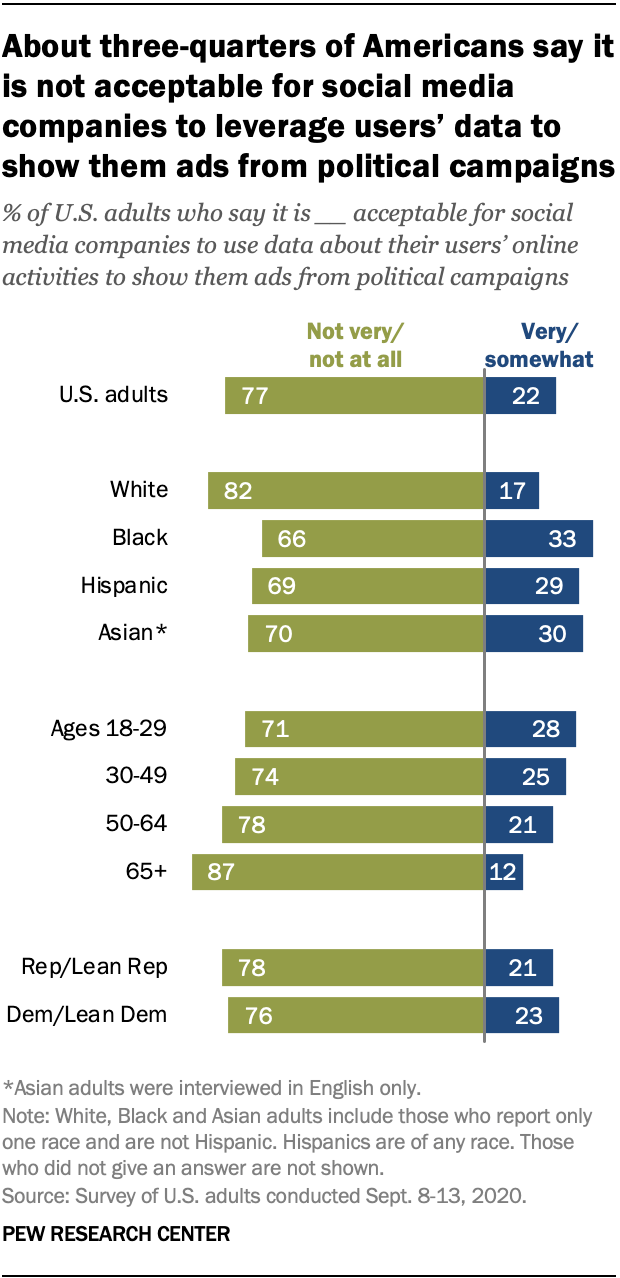Specify some key components in this picture. The blue bar represents a high degree of certainty, with respondents indicating that they are very or somewhat confident in their answer. The race and age range most likely to accept social media companies using their data for political ads are Black individuals and those ages 18-29. 